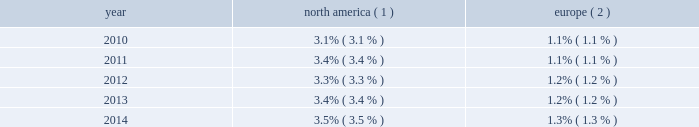Royal caribbean cruises ltd .
15 from two to 17 nights throughout south america , the caribbean and europe .
Additionally , we announced that majesty of the seas will be redeployed from royal caribbean international to pullmantur in 2016 .
Pullmantur serves the contemporary segment of the spanish , portuguese and latin american cruise mar- kets .
Pullmantur 2019s strategy is to attract cruise guests from these target markets by providing a variety of cruising options and onboard activities directed at couples and families traveling with children .
Over the last few years , pullmantur has systematically increased its focus on latin america and has expanded its pres- ence in that market .
In order to facilitate pullmantur 2019s ability to focus on its core cruise business , on march 31 , 2014 , pullmantur sold the majority of its interest in its non-core busi- nesses .
These non-core businesses included pullmantur 2019s land-based tour operations , travel agency and 49% ( 49 % ) interest in its air business .
In connection with the sale agreement , we retained a 19% ( 19 % ) interest in each of the non-core businesses as well as 100% ( 100 % ) ownership of the aircraft which are being dry leased to pullmantur air .
See note 1 .
General and note 6 .
Other assets to our consolidated financial statements under item 8 .
Financial statements and supplementary data for further details .
Cdf croisi e8res de france we currently operate two ships with an aggregate capacity of approximately 2800 berths under our cdf croisi e8res de france brand .
Cdf croisi e8res de france offers seasonal itineraries to the mediterranean , europe and caribbean .
During the winter season , zenith is deployed to the pullmantur brand for sailings in south america .
Cdf croisi e8res de france is designed to serve the contemporary segment of the french cruise market by providing a brand tailored for french cruise guests .
Tui cruises tui cruises is a joint venture owned 50% ( 50 % ) by us and 50% ( 50 % ) by tui ag , a german tourism and shipping com- pany , and is designed to serve the contemporary and premium segments of the german cruise market by offering a product tailored for german guests .
All onboard activities , services , shore excursions and menu offerings are designed to suit the preferences of this target market .
Tui cruises operates three ships , mein schiff 1 , mein schiff 2 and mein schiff 3 , with an aggregate capacity of approximately 6300 berths .
In addition , tui cruises currently has three newbuild ships on order at the finnish meyer turku yard with an aggregate capacity of approximately 7500 berths : mein schiff 4 , scheduled for delivery in the second quarter of 2015 , mein schiff 5 , scheduled for delivery in the third quarter of 2016 and mein schiff 6 , scheduled for delivery in the second quarter of 2017 .
In november 2014 , we formed a strategic partnership with ctrip.com international ltd .
( 201cctrip 201d ) , a chinese travel service provider , to operate a new cruise brand known as skysea cruises .
Skysea cruises will offer a custom-tailored product for chinese cruise guests operating the ship purchased from celebrity cruises .
The new cruise line will begin service in the second quarter of 2015 .
We and ctrip each own 35% ( 35 % ) of the new company , skysea holding , with the balance being owned by skysea holding management and a private equity fund .
Industry cruising is considered a well-established vacation sector in the north american market , a growing sec- tor over the long term in the european market and a developing but promising sector in several other emerging markets .
Industry data indicates that market penetration rates are still low and that a significant portion of cruise guests carried are first-time cruisers .
We believe this presents an opportunity for long-term growth and a potential for increased profitability .
The table details market penetration rates for north america and europe computed based on the number of annual cruise guests as a percentage of the total population : america ( 1 ) europe ( 2 ) .
( 1 ) source : our estimates are based on a combination of data obtained from publicly available sources including the interna- tional monetary fund and cruise lines international association ( 201cclia 201d ) .
Rates are based on cruise guests carried for at least two consecutive nights .
Includes the united states of america and canada .
( 2 ) source : our estimates are based on a combination of data obtained from publicly available sources including the interna- tional monetary fund and clia europe , formerly european cruise council .
We estimate that the global cruise fleet was served by approximately 457000 berths on approximately 283 ships at the end of 2014 .
There are approximately 33 ships with an estimated 98650 berths that are expected to be placed in service in the global cruise market between 2015 and 2019 , although it is also possible that ships could be ordered or taken out of service during these periods .
We estimate that the global cruise industry carried 22.0 million cruise guests in 2014 compared to 21.3 million cruise guests carried in 2013 and 20.9 million cruise guests carried in 2012 .
Part i .
What is the anticipated increase in the number of global cruise fleet berths from 2015 to 2019? 
Computations: (98650 / 457000)
Answer: 0.21586. Royal caribbean cruises ltd .
15 from two to 17 nights throughout south america , the caribbean and europe .
Additionally , we announced that majesty of the seas will be redeployed from royal caribbean international to pullmantur in 2016 .
Pullmantur serves the contemporary segment of the spanish , portuguese and latin american cruise mar- kets .
Pullmantur 2019s strategy is to attract cruise guests from these target markets by providing a variety of cruising options and onboard activities directed at couples and families traveling with children .
Over the last few years , pullmantur has systematically increased its focus on latin america and has expanded its pres- ence in that market .
In order to facilitate pullmantur 2019s ability to focus on its core cruise business , on march 31 , 2014 , pullmantur sold the majority of its interest in its non-core busi- nesses .
These non-core businesses included pullmantur 2019s land-based tour operations , travel agency and 49% ( 49 % ) interest in its air business .
In connection with the sale agreement , we retained a 19% ( 19 % ) interest in each of the non-core businesses as well as 100% ( 100 % ) ownership of the aircraft which are being dry leased to pullmantur air .
See note 1 .
General and note 6 .
Other assets to our consolidated financial statements under item 8 .
Financial statements and supplementary data for further details .
Cdf croisi e8res de france we currently operate two ships with an aggregate capacity of approximately 2800 berths under our cdf croisi e8res de france brand .
Cdf croisi e8res de france offers seasonal itineraries to the mediterranean , europe and caribbean .
During the winter season , zenith is deployed to the pullmantur brand for sailings in south america .
Cdf croisi e8res de france is designed to serve the contemporary segment of the french cruise market by providing a brand tailored for french cruise guests .
Tui cruises tui cruises is a joint venture owned 50% ( 50 % ) by us and 50% ( 50 % ) by tui ag , a german tourism and shipping com- pany , and is designed to serve the contemporary and premium segments of the german cruise market by offering a product tailored for german guests .
All onboard activities , services , shore excursions and menu offerings are designed to suit the preferences of this target market .
Tui cruises operates three ships , mein schiff 1 , mein schiff 2 and mein schiff 3 , with an aggregate capacity of approximately 6300 berths .
In addition , tui cruises currently has three newbuild ships on order at the finnish meyer turku yard with an aggregate capacity of approximately 7500 berths : mein schiff 4 , scheduled for delivery in the second quarter of 2015 , mein schiff 5 , scheduled for delivery in the third quarter of 2016 and mein schiff 6 , scheduled for delivery in the second quarter of 2017 .
In november 2014 , we formed a strategic partnership with ctrip.com international ltd .
( 201cctrip 201d ) , a chinese travel service provider , to operate a new cruise brand known as skysea cruises .
Skysea cruises will offer a custom-tailored product for chinese cruise guests operating the ship purchased from celebrity cruises .
The new cruise line will begin service in the second quarter of 2015 .
We and ctrip each own 35% ( 35 % ) of the new company , skysea holding , with the balance being owned by skysea holding management and a private equity fund .
Industry cruising is considered a well-established vacation sector in the north american market , a growing sec- tor over the long term in the european market and a developing but promising sector in several other emerging markets .
Industry data indicates that market penetration rates are still low and that a significant portion of cruise guests carried are first-time cruisers .
We believe this presents an opportunity for long-term growth and a potential for increased profitability .
The table details market penetration rates for north america and europe computed based on the number of annual cruise guests as a percentage of the total population : america ( 1 ) europe ( 2 ) .
( 1 ) source : our estimates are based on a combination of data obtained from publicly available sources including the interna- tional monetary fund and cruise lines international association ( 201cclia 201d ) .
Rates are based on cruise guests carried for at least two consecutive nights .
Includes the united states of america and canada .
( 2 ) source : our estimates are based on a combination of data obtained from publicly available sources including the interna- tional monetary fund and clia europe , formerly european cruise council .
We estimate that the global cruise fleet was served by approximately 457000 berths on approximately 283 ships at the end of 2014 .
There are approximately 33 ships with an estimated 98650 berths that are expected to be placed in service in the global cruise market between 2015 and 2019 , although it is also possible that ships could be ordered or taken out of service during these periods .
We estimate that the global cruise industry carried 22.0 million cruise guests in 2014 compared to 21.3 million cruise guests carried in 2013 and 20.9 million cruise guests carried in 2012 .
Part i .
How many berths per ship , to the nearest whole number , should be expected in global cruise market between 2015-2019 , assuming each ship has the same amount? 
Rationale: rounding to nearest whole number , down to 2989
Computations: (98650 / 33)
Answer: 2989.39394. 